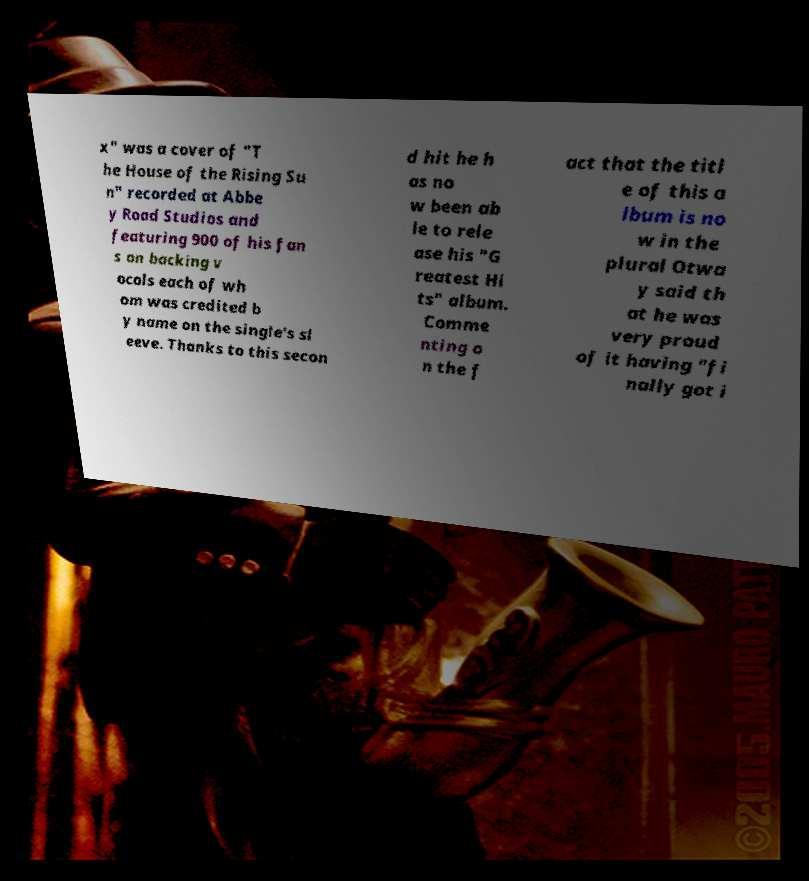Please identify and transcribe the text found in this image. x" was a cover of "T he House of the Rising Su n" recorded at Abbe y Road Studios and featuring 900 of his fan s on backing v ocals each of wh om was credited b y name on the single's sl eeve. Thanks to this secon d hit he h as no w been ab le to rele ase his "G reatest Hi ts" album. Comme nting o n the f act that the titl e of this a lbum is no w in the plural Otwa y said th at he was very proud of it having "fi nally got i 